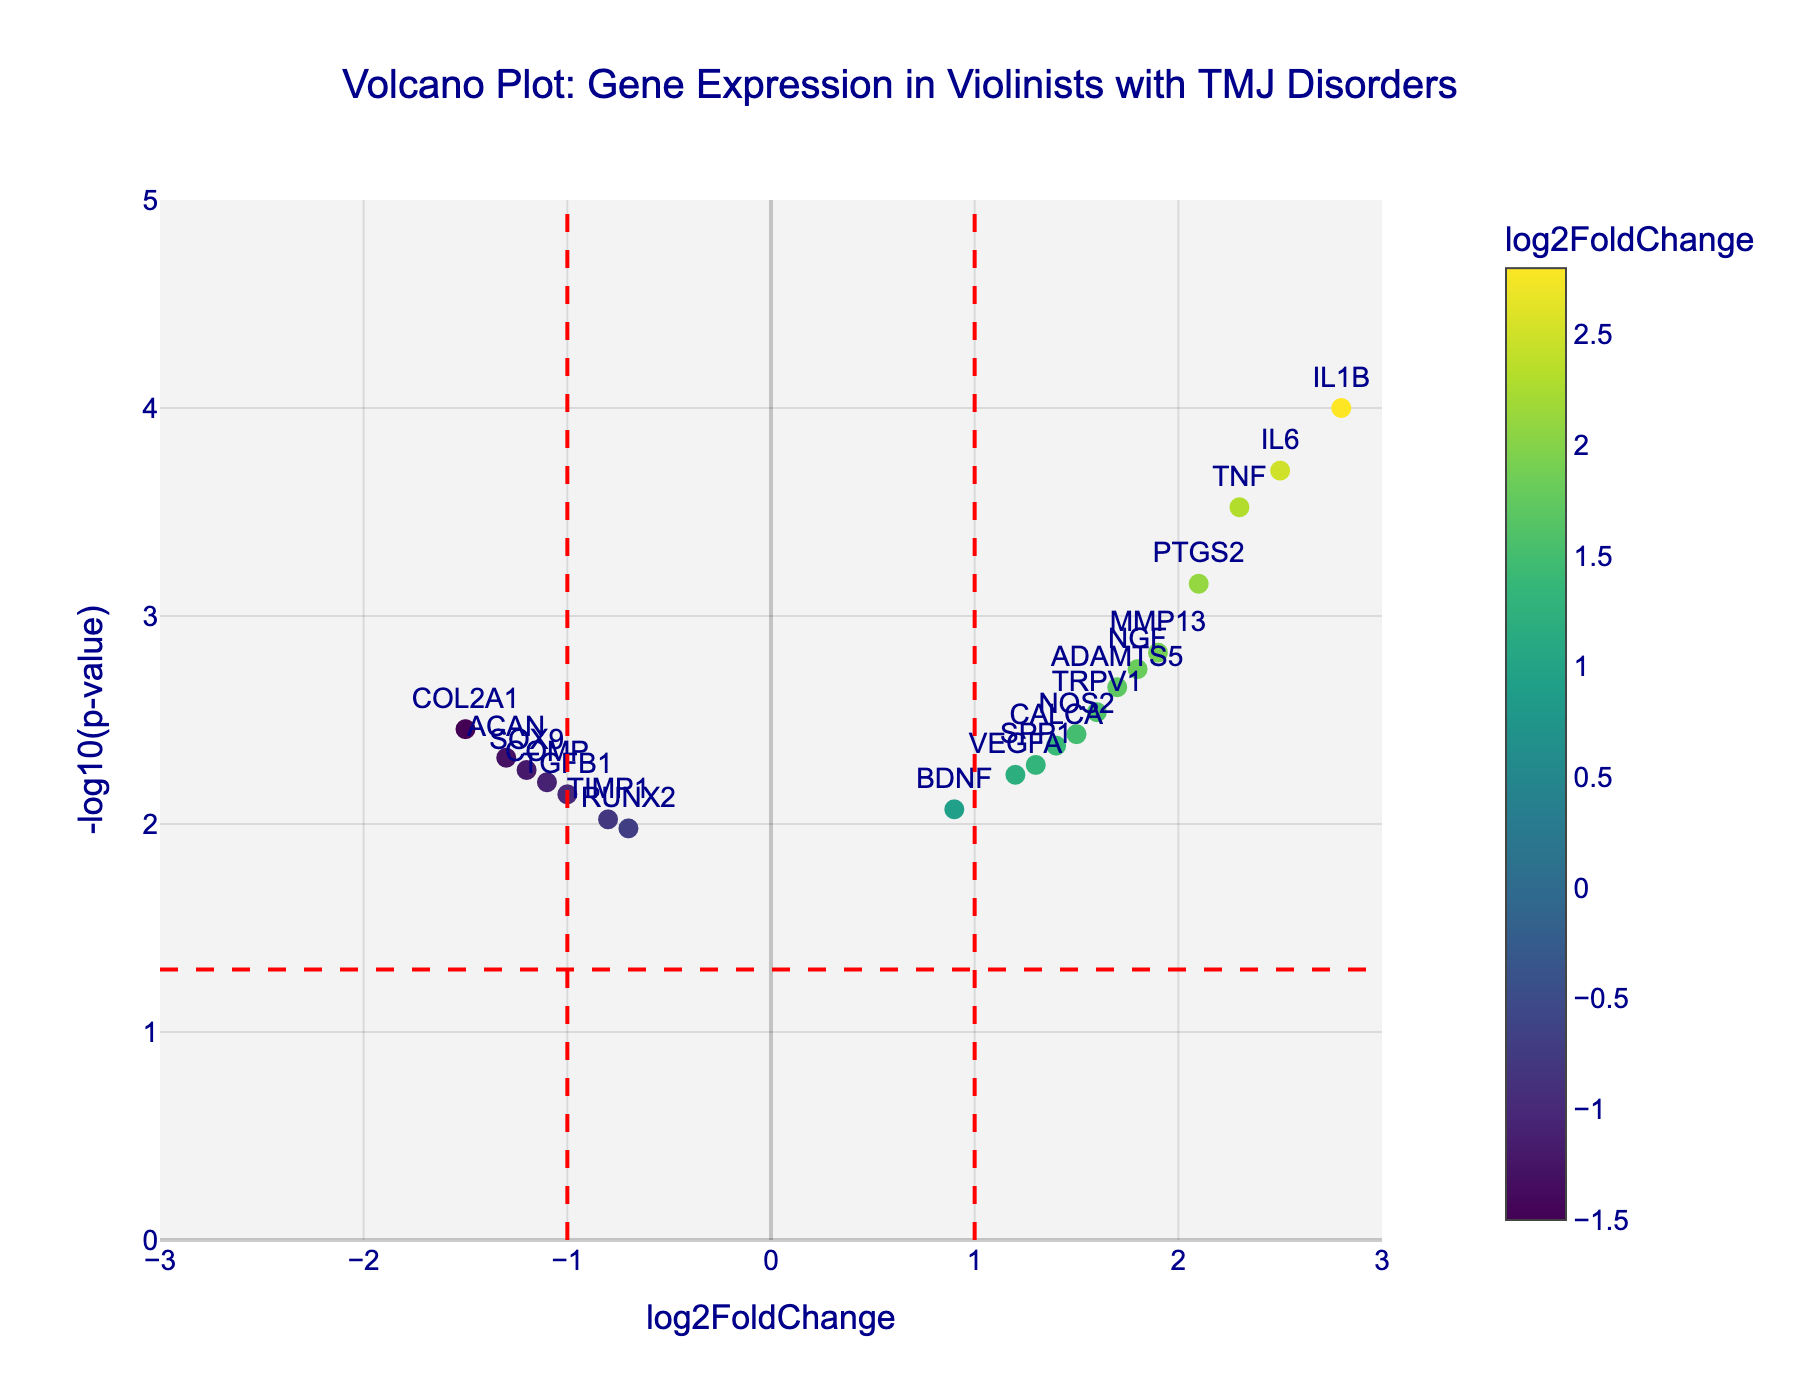What is the title of the figure? The title is located at the top center of the figure, typically in larger font size to draw attention. In this case, it reads "Volcano Plot: Gene Expression in Violinists with TMJ Disorders."
Answer: Volcano Plot: Gene Expression in Violinists with TMJ Disorders What does the x-axis represent? The x-axis is typically labeled to indicate what variable it represents. In this figure, the x-axis title is "log2FoldChange."
Answer: log2FoldChange What does the y-axis represent? The y-axis title is found along the vertical side of the plot, indicating the measured variable. Here, it is labeled "-log10(p-value)."
Answer: -log10(p-value) How many genes are labeled on the plot? By counting the number of text labels (gene names) visible on the plot, we can determine the number of genes. There are 19 labels corresponding to different genes.
Answer: 19 Which gene has the highest log2FoldChange? By looking for the data point farthest to the right on the x-axis, we find that IL1B has the highest log2FoldChange of 2.8.
Answer: IL1B Which gene has the lowest p-value? The lowest p-value corresponds to the highest -log10(p-value) on the y-axis. IL1B has the highest -log10(pvalue) of 4, indicating the lowest p-value.
Answer: IL1B Which genes have a log2FoldChange less than -1 and a significant p-value (p < 0.05)? By checking the plot for data points left of -1 on the x-axis and above the red horizontal line (-log10(0.05)=1.3), we find that COL2A1, ACAN, and SOX9 meet these criteria.
Answer: COL2A1, ACAN, SOX9 How many genes have a positive log2FoldChange and a p-value less than 0.002? We find the genes by locating those on the right of the x-axis (positive log2FoldChange) and above -log10(pvalue) of 2.7 (i.e., p-value less than 0.002). These genes are IL1B, TNF, PTGS2, and IL6, totaling to 4.
Answer: 4 What is the range of -log10(p-value) displayed on the y-axis? By observing the y-axis numbers and grid, the minimum value is 0 and the maximum value is 5.
Answer: 0 to 5 Compare the log2FoldChange of TNF and IL6. Which one is higher? By locating both genes on the plot, we see TNF has a log2FoldChange of 2.3 and IL6 has a log2FoldChange of 2.5. Thus, IL6 is higher.
Answer: IL6 